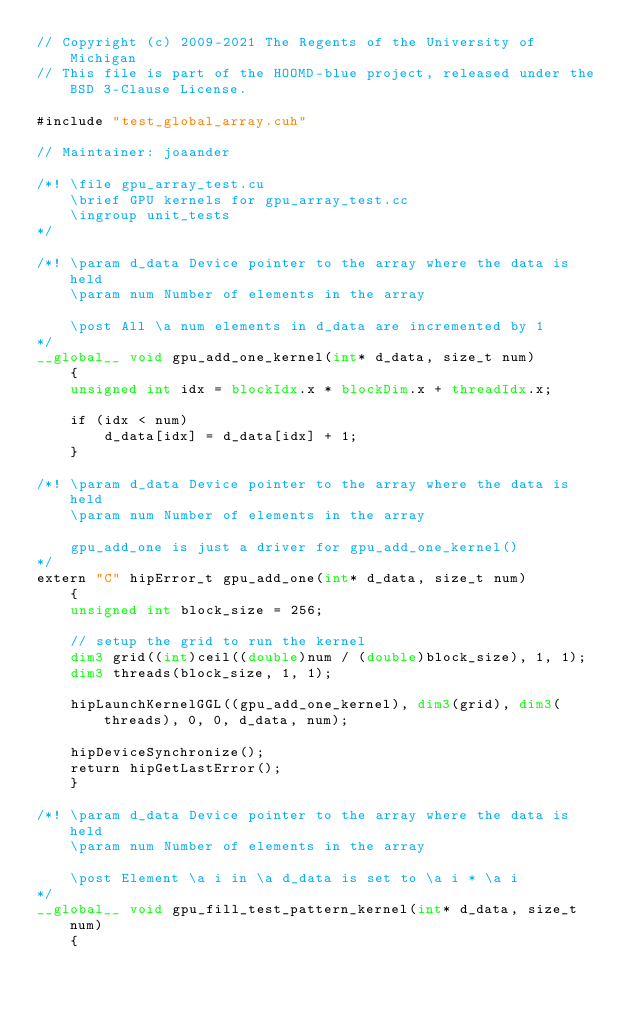<code> <loc_0><loc_0><loc_500><loc_500><_Cuda_>// Copyright (c) 2009-2021 The Regents of the University of Michigan
// This file is part of the HOOMD-blue project, released under the BSD 3-Clause License.

#include "test_global_array.cuh"

// Maintainer: joaander

/*! \file gpu_array_test.cu
    \brief GPU kernels for gpu_array_test.cc
    \ingroup unit_tests
*/

/*! \param d_data Device pointer to the array where the data is held
    \param num Number of elements in the array

    \post All \a num elements in d_data are incremented by 1
*/
__global__ void gpu_add_one_kernel(int* d_data, size_t num)
    {
    unsigned int idx = blockIdx.x * blockDim.x + threadIdx.x;

    if (idx < num)
        d_data[idx] = d_data[idx] + 1;
    }

/*! \param d_data Device pointer to the array where the data is held
    \param num Number of elements in the array

    gpu_add_one is just a driver for gpu_add_one_kernel()
*/
extern "C" hipError_t gpu_add_one(int* d_data, size_t num)
    {
    unsigned int block_size = 256;

    // setup the grid to run the kernel
    dim3 grid((int)ceil((double)num / (double)block_size), 1, 1);
    dim3 threads(block_size, 1, 1);

    hipLaunchKernelGGL((gpu_add_one_kernel), dim3(grid), dim3(threads), 0, 0, d_data, num);

    hipDeviceSynchronize();
    return hipGetLastError();
    }

/*! \param d_data Device pointer to the array where the data is held
    \param num Number of elements in the array

    \post Element \a i in \a d_data is set to \a i * \a i
*/
__global__ void gpu_fill_test_pattern_kernel(int* d_data, size_t num)
    {</code> 